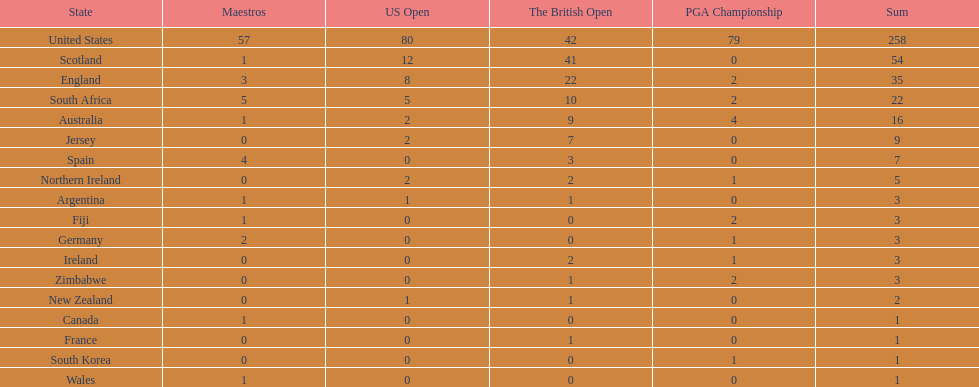Is the united stated or scotland better? United States. 